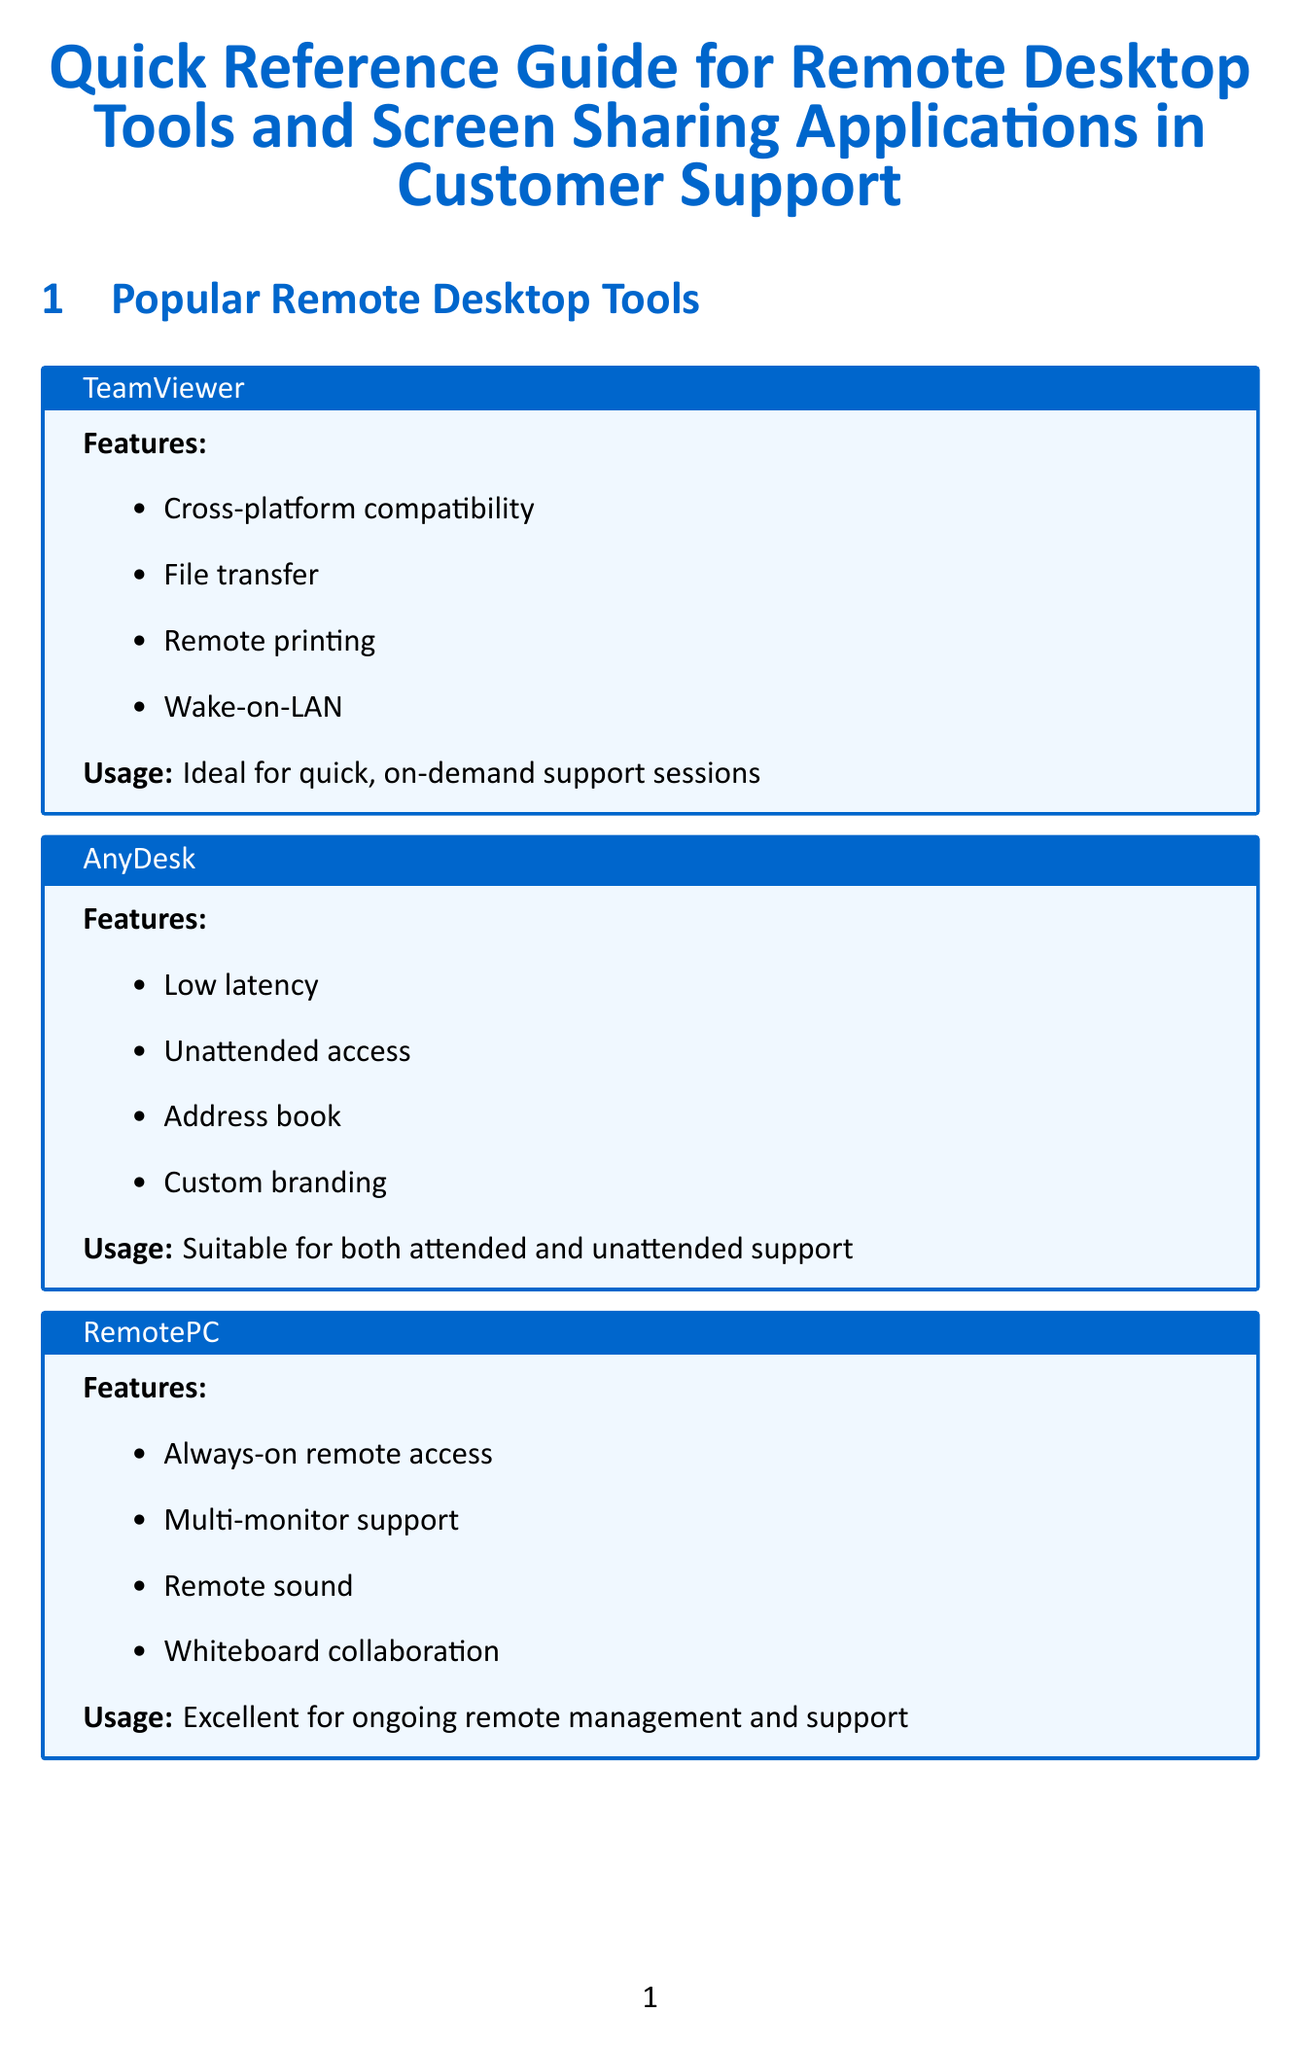What tool is ideal for quick, on-demand support sessions? The usage section states that TeamViewer is ideal for quick, on-demand support sessions.
Answer: TeamViewer What feature does AnyDesk offer for accessing computers without supervision? The features section mentions that AnyDesk supports unattended access.
Answer: Unattended access What is one of the best practices for remote support? The best practices section includes the recommendation to always ask for permission before taking control of a user's system.
Answer: Ask for permission What issue should you troubleshoot if a remote access session has poor performance? The troubleshooting section lists poor performance or lag as a common issue that needs addressing.
Answer: Poor performance or lag What is mentioned as a security consideration for remote access tools? The security considerations section highlights the importance of using multi-factor authentication for remote access tools.
Answer: Multi-factor authentication Which application is ideal for organizations using Microsoft ecosystems? The usage description for Microsoft Teams indicates that it is ideal for organizations using Microsoft ecosystems.
Answer: Microsoft Teams What type of remote desktop tool is RemotePC categorized under? The document categorizes RemotePC as a remote desktop tool for ongoing remote management and support.
Answer: Ongoing remote management and support What should be documented during a remote support session? The best practices section advises to document all actions taken during the remote session.
Answer: All actions taken What is a key feature of Zoom for enhancing collaborative troubleshooting? The features of Zoom include screen annotation, which enhances collaborative troubleshooting.
Answer: Screen annotation 